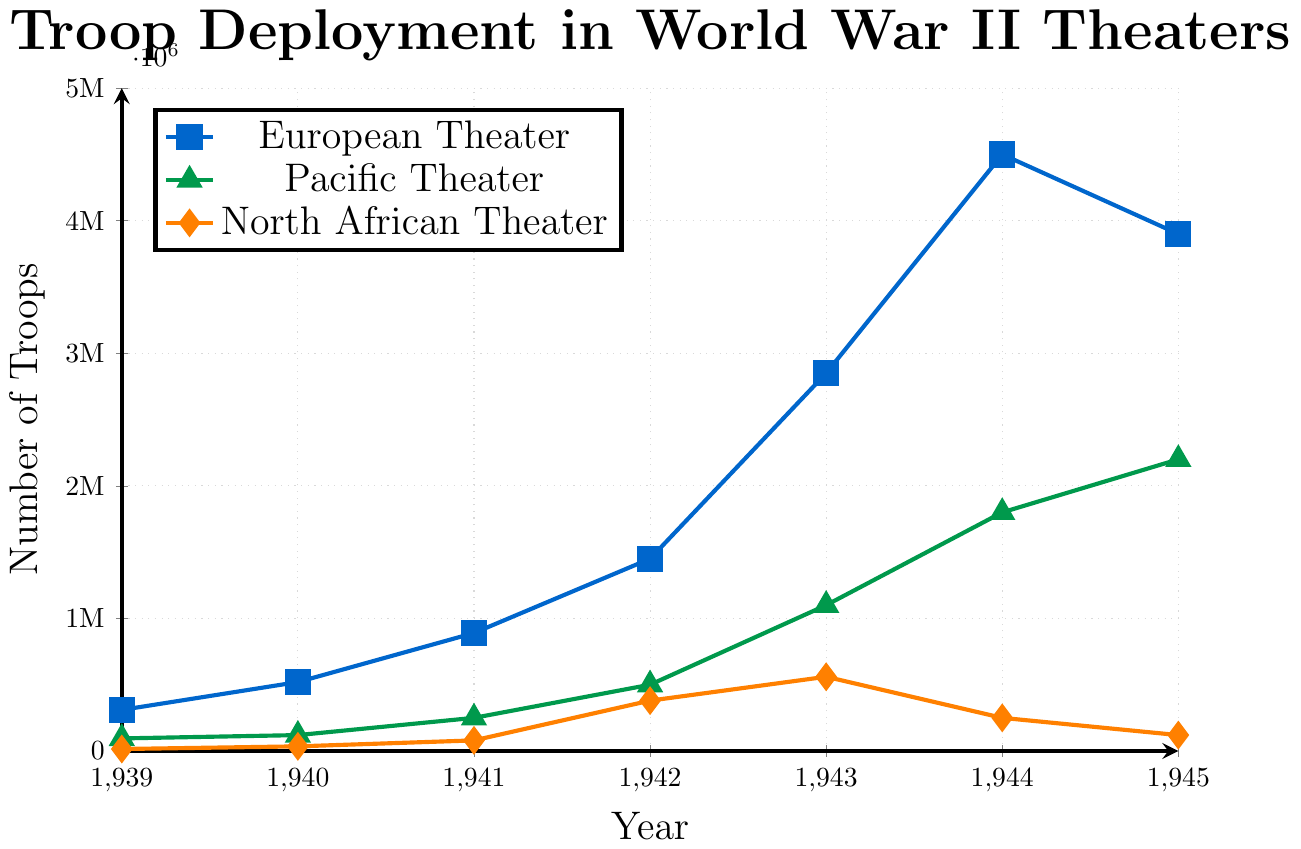How many more troops were deployed in the European Theater than in the North African Theater in 1943? In 1943, the European Theater had 2,850,000 troops, and the North African Theater had 560,000 troops. The difference is 2,850,000 - 560,000 = 2,290,000 troops.
Answer: 2,290,000 Which theater had the highest number of troops deployed in 1945, and what was that number? The European Theater had the highest number of troops deployed in 1945. According to the plot, in 1945, the European Theater had 3,900,000 troops.
Answer: European Theater, 3,900,000 What was the combined total of troops deployed in all theaters in 1942? In 1942, the numbers are: European Theater: 1,450,000, Pacific Theater: 500,000, North African Theater: 380,000. Combining these gives 1,450,000 + 500,000 + 380,000 = 2,330,000 troops.
Answer: 2,330,000 By what factor did troop deployments in the Pacific Theater increase from 1939 to 1945? In 1939, there were 95,000 troops in the Pacific Theater. In 1945, there were 2,200,000 troops. The factor increase would be 2,200,000 / 95,000 ≈ 23.16.
Answer: 23.16 Which theater experienced the largest relative increase in troop numbers from 1941 to 1942? From 1941 to 1942, the troop counts are: European Theater: 890,000 to 1,450,000; Pacific Theater: 250,000 to 500,000; North African Theater: 80,000 to 380,000. Calculate the relative increases: European = (1,450,000 - 890,000) / 890,000 ≈ 0.63, Pacific = (500,000 - 250,000) / 250,000 = 1.0, North African = (380,000 - 80,000) / 80,000 = 3.75. The North African Theater had the largest relative increase.
Answer: North African Theater Which year had the steepest increase in troop deployment for the Pacific Theater? For the Pacific Theater, check the increments: 1939-1940 = 120,000 - 95,000 = 25,000, 1940-1941 = 250,000 - 120,000 = 130,000, 1941-1942 = 500,000 - 250,000 = 250,000, 1942-1943 = 1,100,000 - 500,000 = 600,000, 1943-1944 = 1,800,000 - 1,100,000 = 700,000, 1944-1945 = 2,200,000 - 1,800,000 = 400,000. The steepest increase was from 1943 to 1944 with an increase of 700,000 troops.
Answer: 1943-1944 In what year did the North African Theater see its peak troop deployment, and what was the number? The peak for the North African Theater occurred in 1943, with troop deployment reaching 560,000.
Answer: 1943, 560,000 Compare the troop deployments in the European and Pacific Theaters in 1944. How much higher is the deployment in the European Theater? In 1944, the European Theater had 4,500,000 troops while the Pacific Theater had 1,800,000 troops. The difference is 4,500,000 - 1,800,000 = 2,700,000 troops.
Answer: 2,700,000 What is the average number of troops deployed in the Pacific Theater from 1939 to 1945? Troop numbers for the Pacific Theater: 1939 = 95,000, 1940 = 120,000, 1941 = 250,000, 1942 = 500,000, 1943 = 1,100,000, 1944 = 1,800,000, 1945 = 2,200,000. Sum these values: 95,000 + 120,000 + 250,000 + 500,000 + 1,100,000 + 1,800,000 + 2,200,000 = 6,065,000. Average = 6,065,000 / 7 ≈ 866,429.
Answer: 866,429 troops How did the number of troops in the North African Theater change from 1943 to 1944? From 1943 to 1944, the number of troops in the North African Theater decreased from 560,000 to 250,000. The change is 560,000 - 250,000 = 310,000 troops.
Answer: Decreased by 310,000 